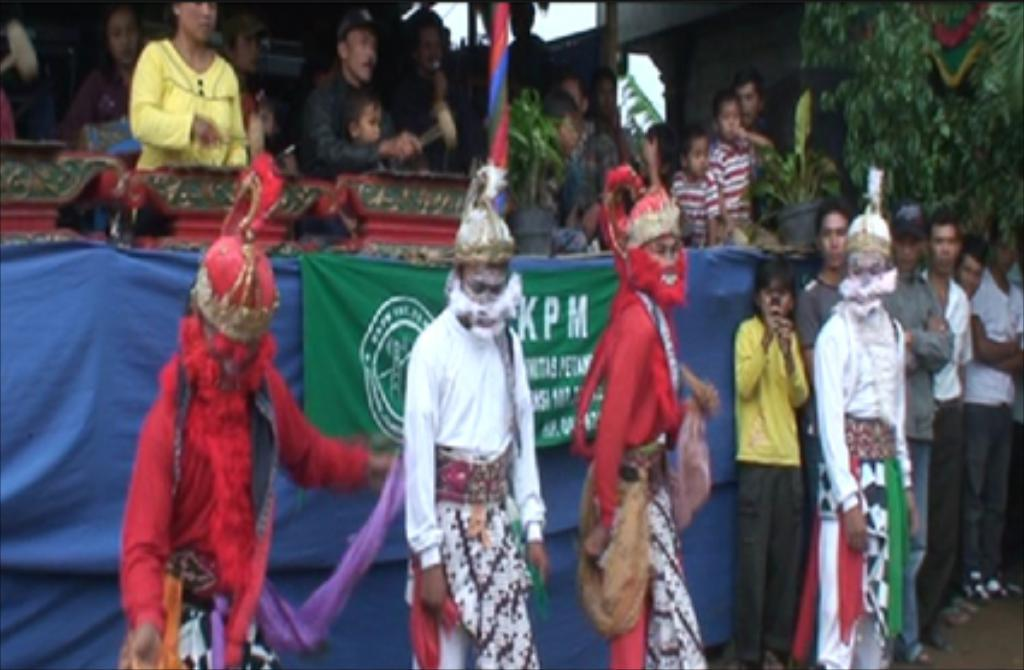What is the main subject in the image? There is a person standing in the image. What is located in the center of the image? There is a banner with text in the center of the image. What can be seen in the background of the image? There are plants and a wall in the background of the image. What type of game is being played in the image? There is no game being played in the image; it features a person standing with a banner and a background of plants and a wall. Can you see any coils in the image? There are no coils present in the image. 